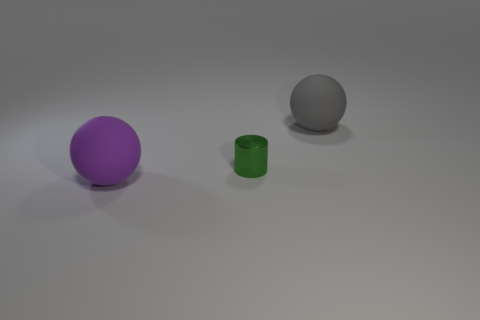Add 3 small things. How many objects exist? 6 Subtract all balls. How many objects are left? 1 Subtract all purple balls. How many balls are left? 1 Subtract 1 spheres. How many spheres are left? 1 Subtract all gray spheres. Subtract all brown blocks. How many spheres are left? 1 Subtract all green cylinders. How many cyan balls are left? 0 Subtract all gray spheres. Subtract all big cyan matte balls. How many objects are left? 2 Add 3 big matte balls. How many big matte balls are left? 5 Add 1 gray objects. How many gray objects exist? 2 Subtract 0 yellow cylinders. How many objects are left? 3 